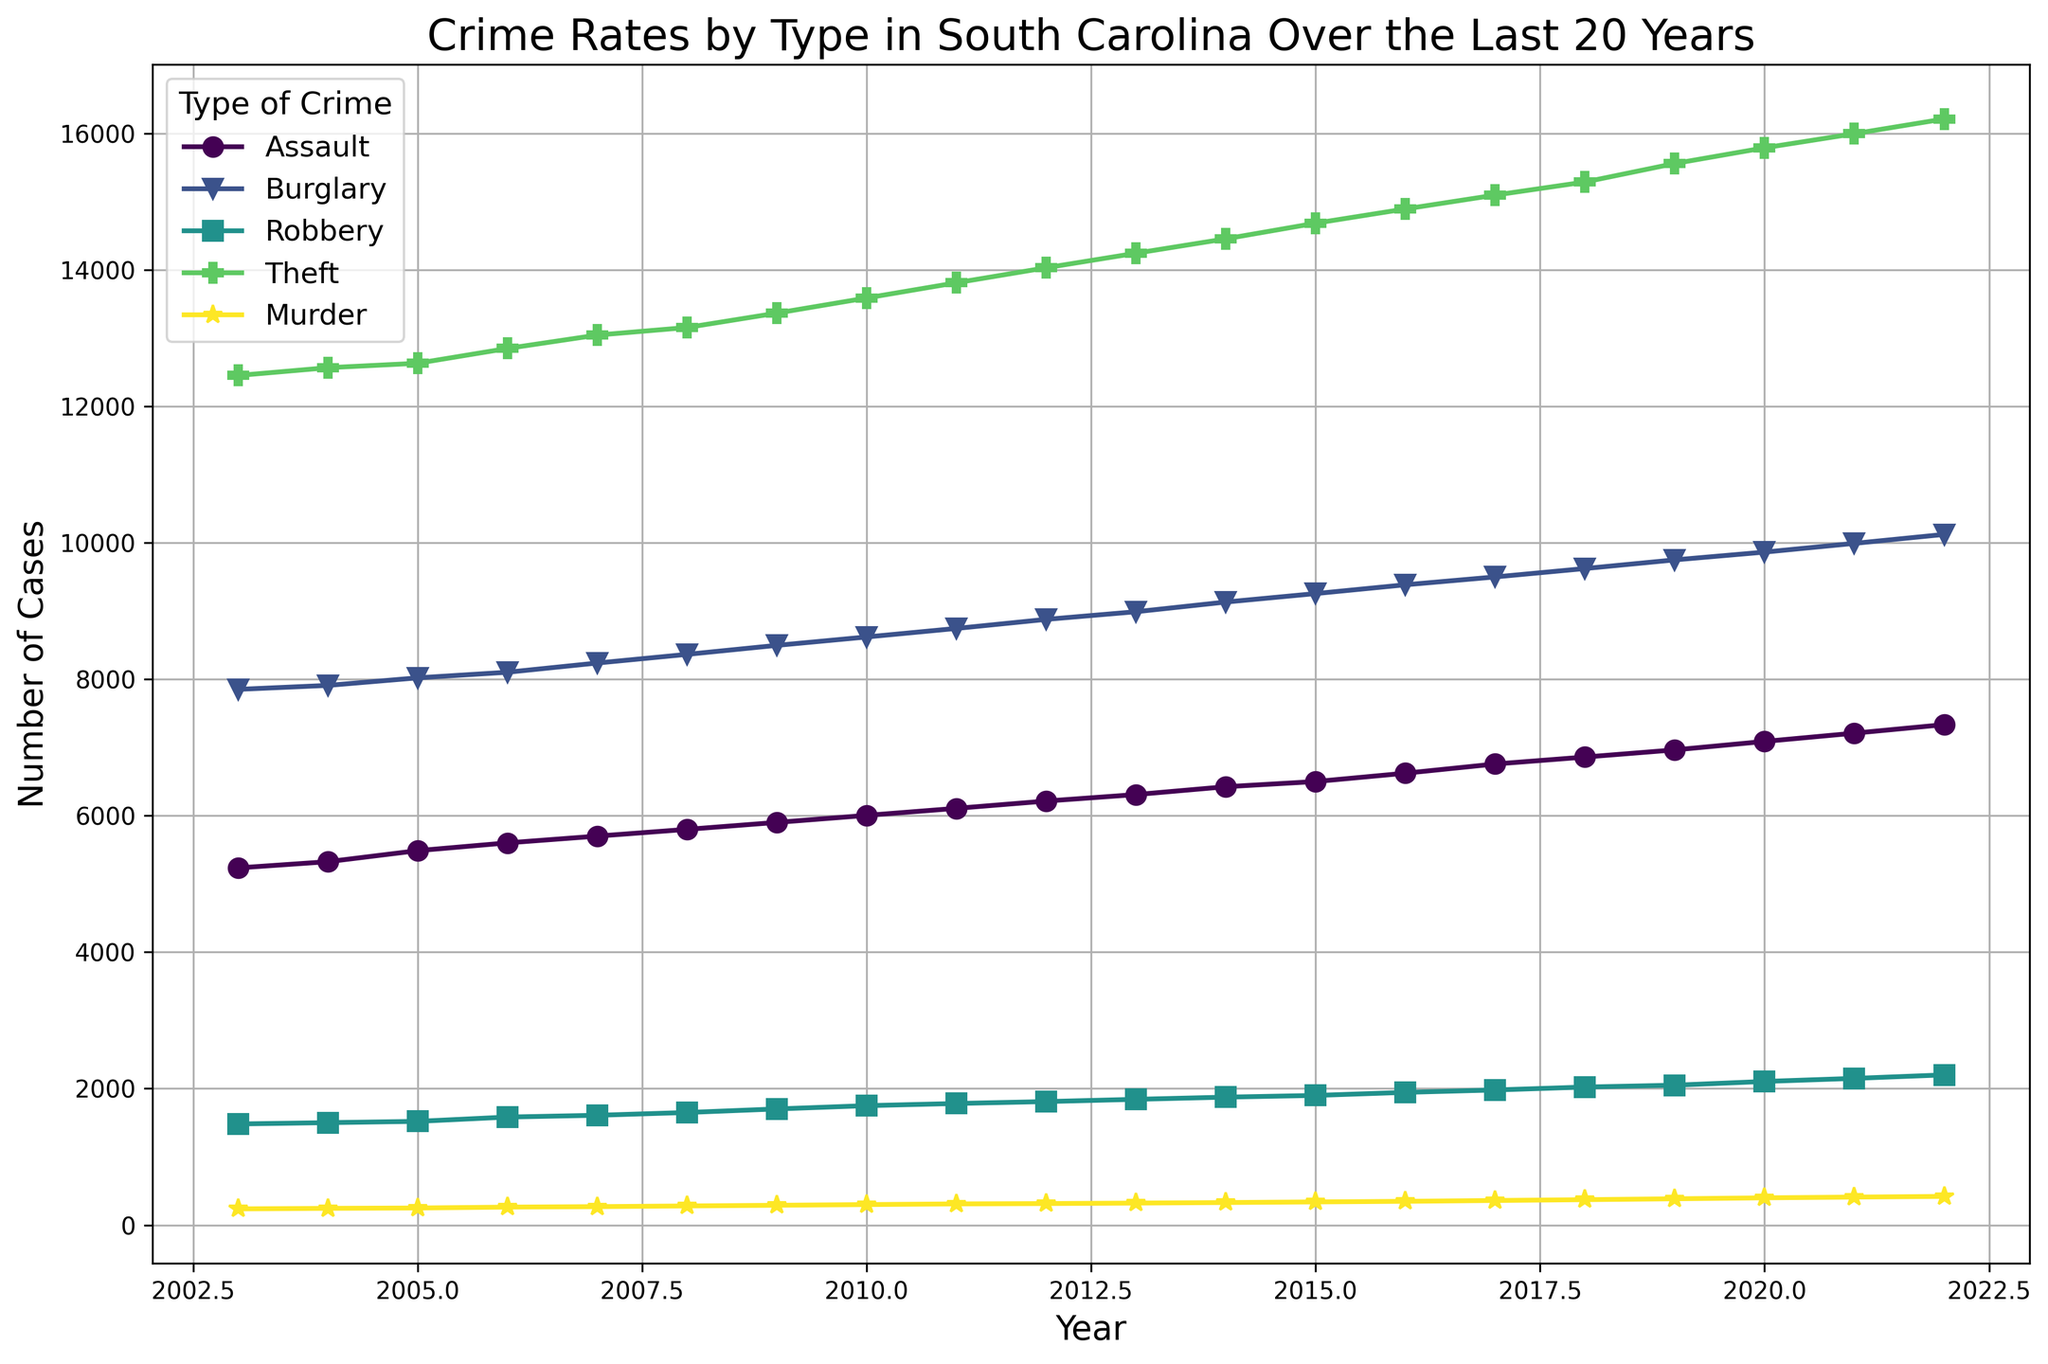What was the highest crime rate in 2022? Look at the year 2022 and identify the crime with the highest number of cases. The highest count belongs to Theft.
Answer: Theft How did the rate of Assault change from 2003 to 2022? Check the initial rate of Assault in 2003 and compare it to the rate in 2022. Assault cases increased from 5235 to 7335.
Answer: Increased Which crime type had the smallest rate increase over the last 20 years? Calculate the difference between the count from 2022 and 2003 for each crime type. The smallest increase is for Murder (420 - 237 = 183).
Answer: Murder By how much did the count of Robbery change from 2003 to 2012? Calculate the difference in Robbery counts between 2012 and 2003. The change is 1810 - 1482 = 328.
Answer: 328 Which type of crime had the greatest fluctuation in its yearly counts over the 20-year period? Observe the graph for the changes in counts year-by-year for each crime type. Theft shows the greatest fluctuation as it consistently increases each year.
Answer: Theft How many total robbery cases were reported in 2003 and 2022 combined? Add the robbery counts for both years: 1482 (2003) + 2201 (2022) = 3683.
Answer: 3683 Which year saw the biggest jump in murder cases compared to the previous year? Identify the year with the largest increase in Murder cases compared to the previous year by looking at all year-to-year differences. From 2020 to 2021, murders increased the most significantly (399 to 410).
Answer: 2021 By what percentage did burglary cases increase from 2003 to 2022? Calculate the percentage increase using the counts: (10123 - 7852) / 7852 * 100 ≈ 28.97%.
Answer: ~29% Which crime type consistently showed an upward trend over the 20-year period? Look at the lines in the graph to find the crime that steadily increased each year. All crime types show this trend, but Theft is the most apparent with no declines.
Answer: Theft What are the visual elements used to differentiate between the types of crimes? Observe the graph's components such as colors and markers used for each crime type. Different colors and unique markers (circles, triangles, squares, etc.) are applied.
Answer: Colors and markers 